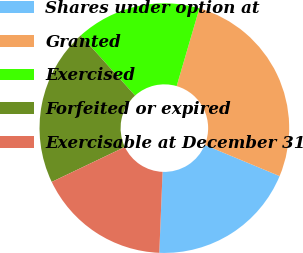<chart> <loc_0><loc_0><loc_500><loc_500><pie_chart><fcel>Shares under option at<fcel>Granted<fcel>Exercised<fcel>Forfeited or expired<fcel>Exercisable at December 31<nl><fcel>19.37%<fcel>26.75%<fcel>16.2%<fcel>20.42%<fcel>17.26%<nl></chart> 